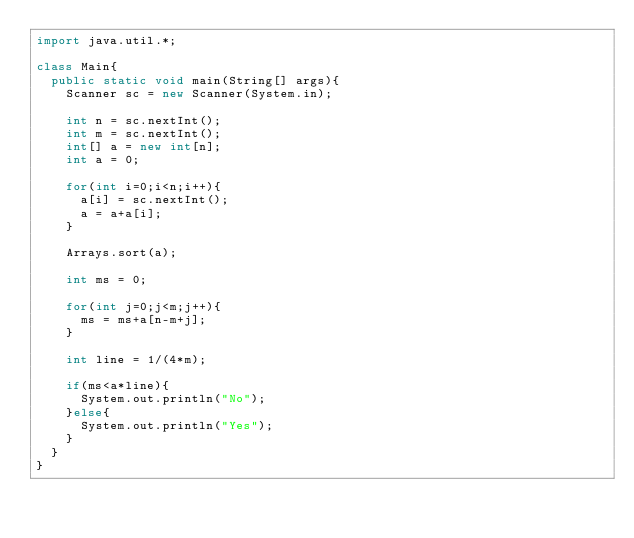<code> <loc_0><loc_0><loc_500><loc_500><_Java_>import java.util.*;
 
class Main{
  public static void main(String[] args){
    Scanner sc = new Scanner(System.in);
    
    int n = sc.nextInt();
    int m = sc.nextInt();
    int[] a = new int[n];
    int a = 0;
    
    for(int i=0;i<n;i++){
      a[i] = sc.nextInt();
      a = a+a[i];
    }
    
    Arrays.sort(a);
    
    int ms = 0;
    
    for(int j=0;j<m;j++){
      ms = ms+a[n-m+j];
    }
    
    int line = 1/(4*m);
    
    if(ms<a*line){
      System.out.println("No");
    }else{
      System.out.println("Yes");
    }
  }
}</code> 